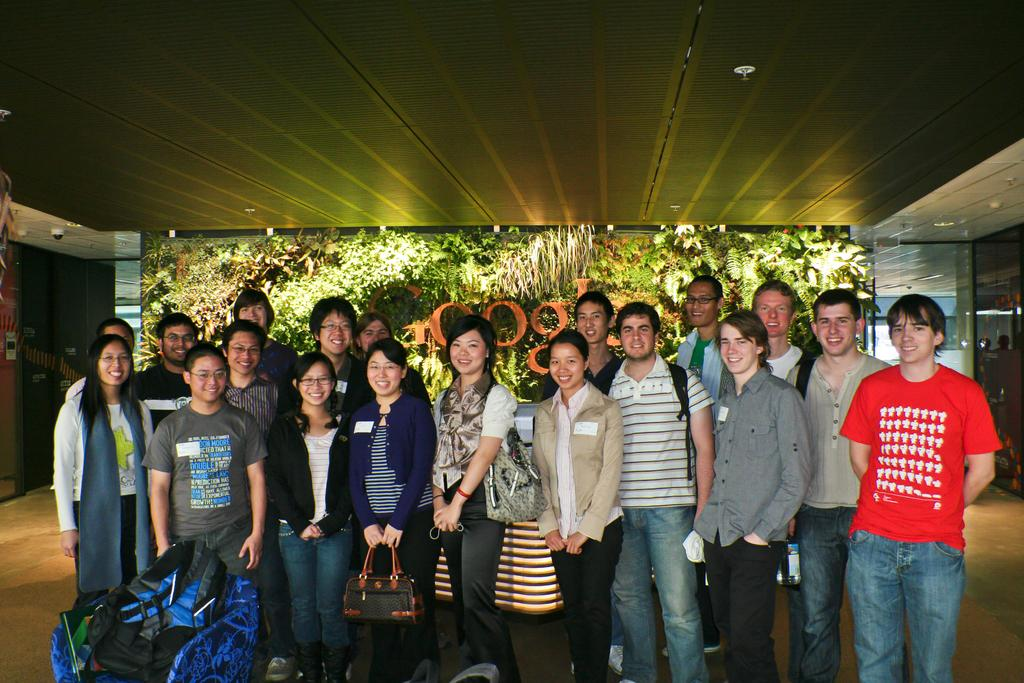What are the people in the image doing? The persons standing on the floor in the image are smiling. What can be seen in the background of the image? There is a name board, plants, and electric lights in the background of the image. What type of beef is being sold at the store in the image? There is no store or beef present in the image; it features persons standing on the floor and elements in the background. What type of army is depicted in the image? There is no army or military presence in the image; it features persons standing on the floor and elements in the background. 